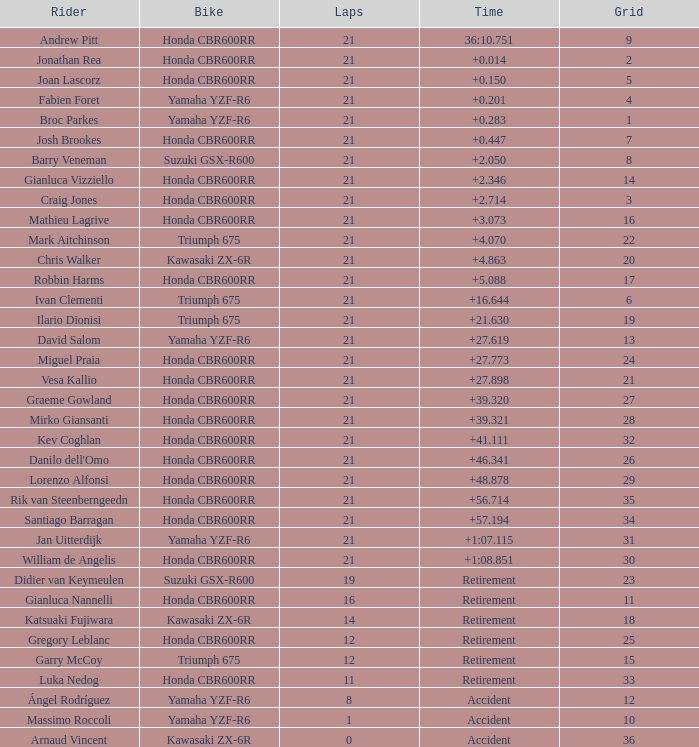What driver had the highest grid position with a time of +0.283? 1.0. 